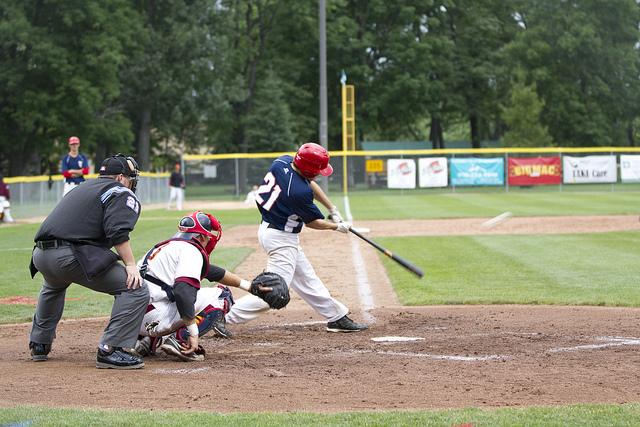How many signs are in the back?
Keep it brief. 8. Is the ball going away from the batter?
Concise answer only. Yes. Is the batter about to run?
Be succinct. Yes. Are they playing football?
Short answer required. No. 